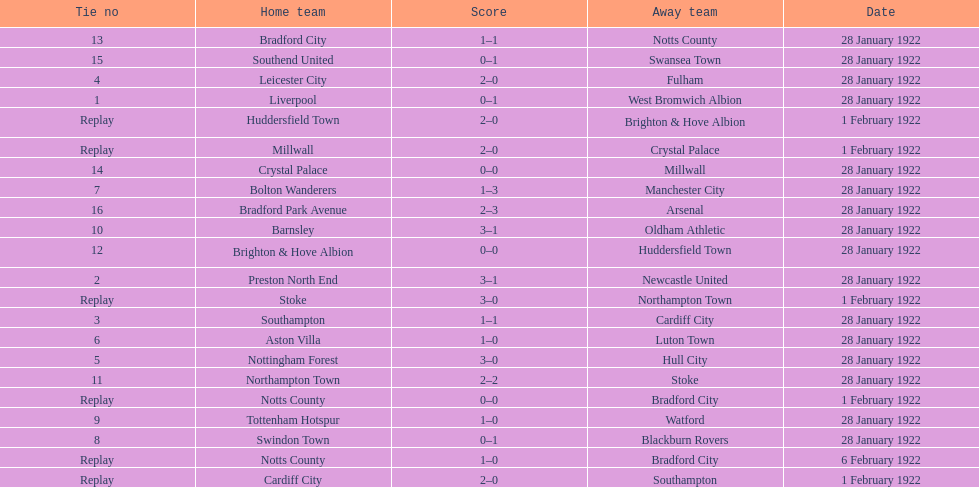What home team had the same score as aston villa on january 28th, 1922? Tottenham Hotspur. 